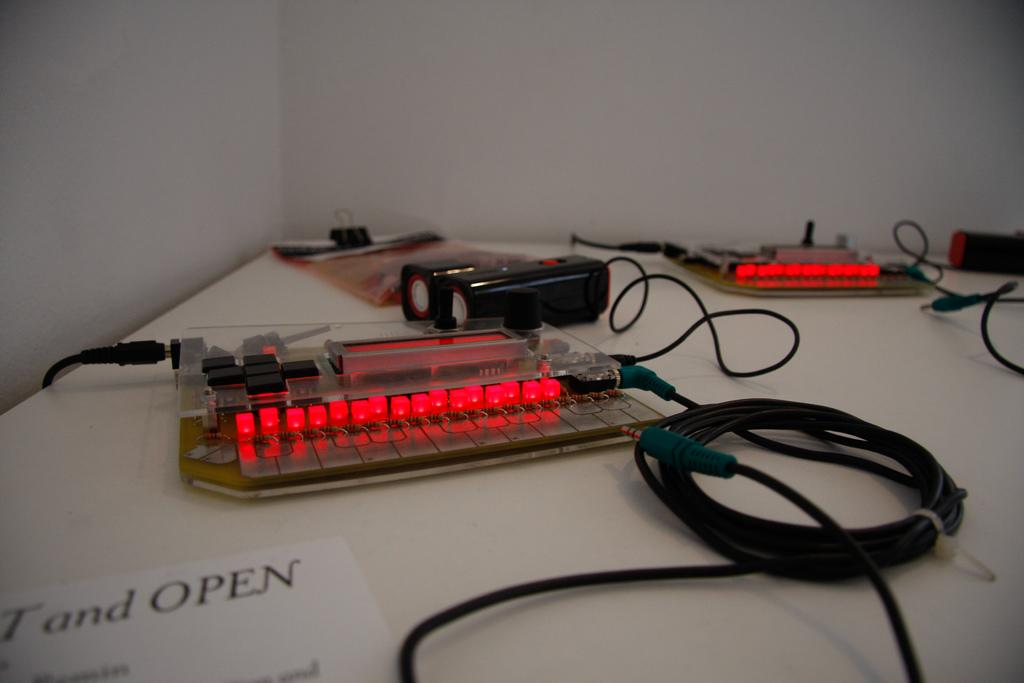What type of objects are on the table in the image? There are electronic components on the table. Where can text be found in the image? The text is on the left side of the image. What type of development can be seen taking place in the image? There is no development taking place in the image; it only shows electronic components on a table and text on the left side. Is there a fight happening in the image? No, there is no fight depicted in the image. 